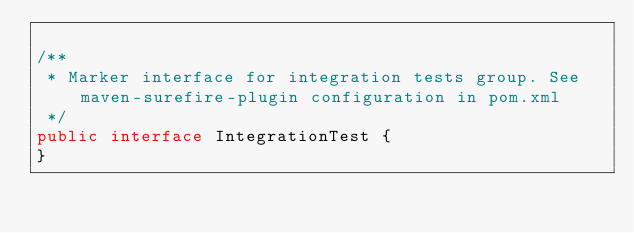Convert code to text. <code><loc_0><loc_0><loc_500><loc_500><_Java_>
/**
 * Marker interface for integration tests group. See maven-surefire-plugin configuration in pom.xml
 */
public interface IntegrationTest {
}
</code> 